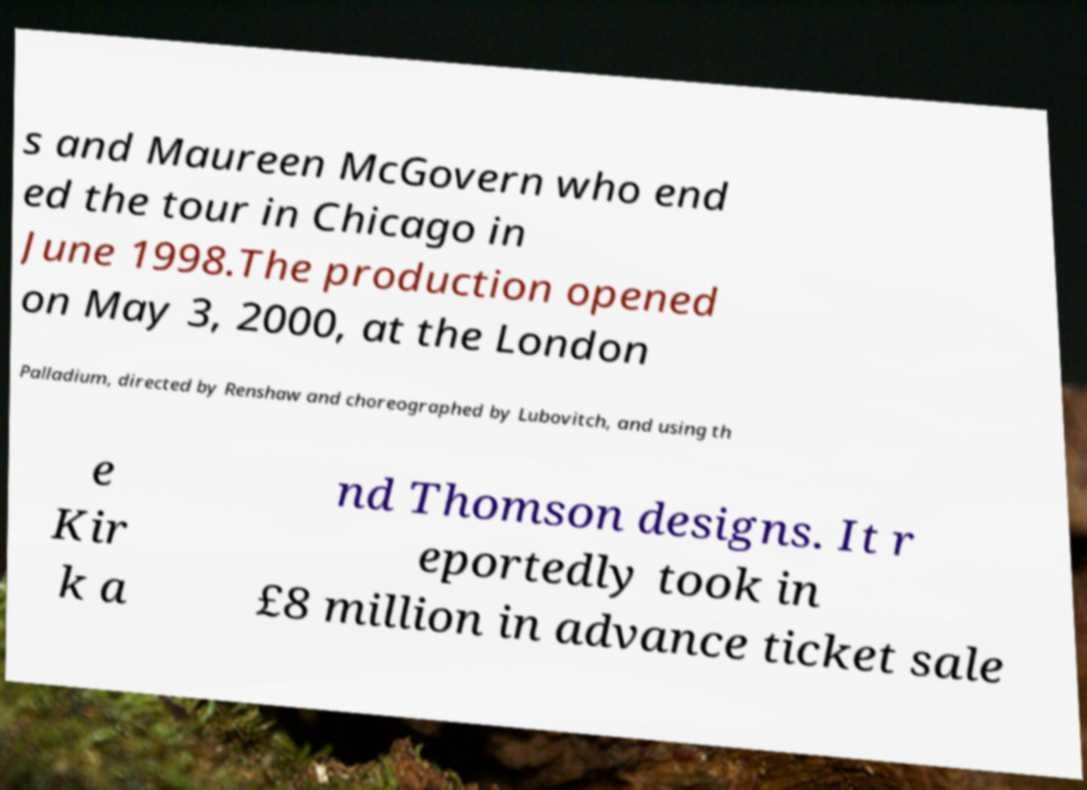What messages or text are displayed in this image? I need them in a readable, typed format. s and Maureen McGovern who end ed the tour in Chicago in June 1998.The production opened on May 3, 2000, at the London Palladium, directed by Renshaw and choreographed by Lubovitch, and using th e Kir k a nd Thomson designs. It r eportedly took in £8 million in advance ticket sale 